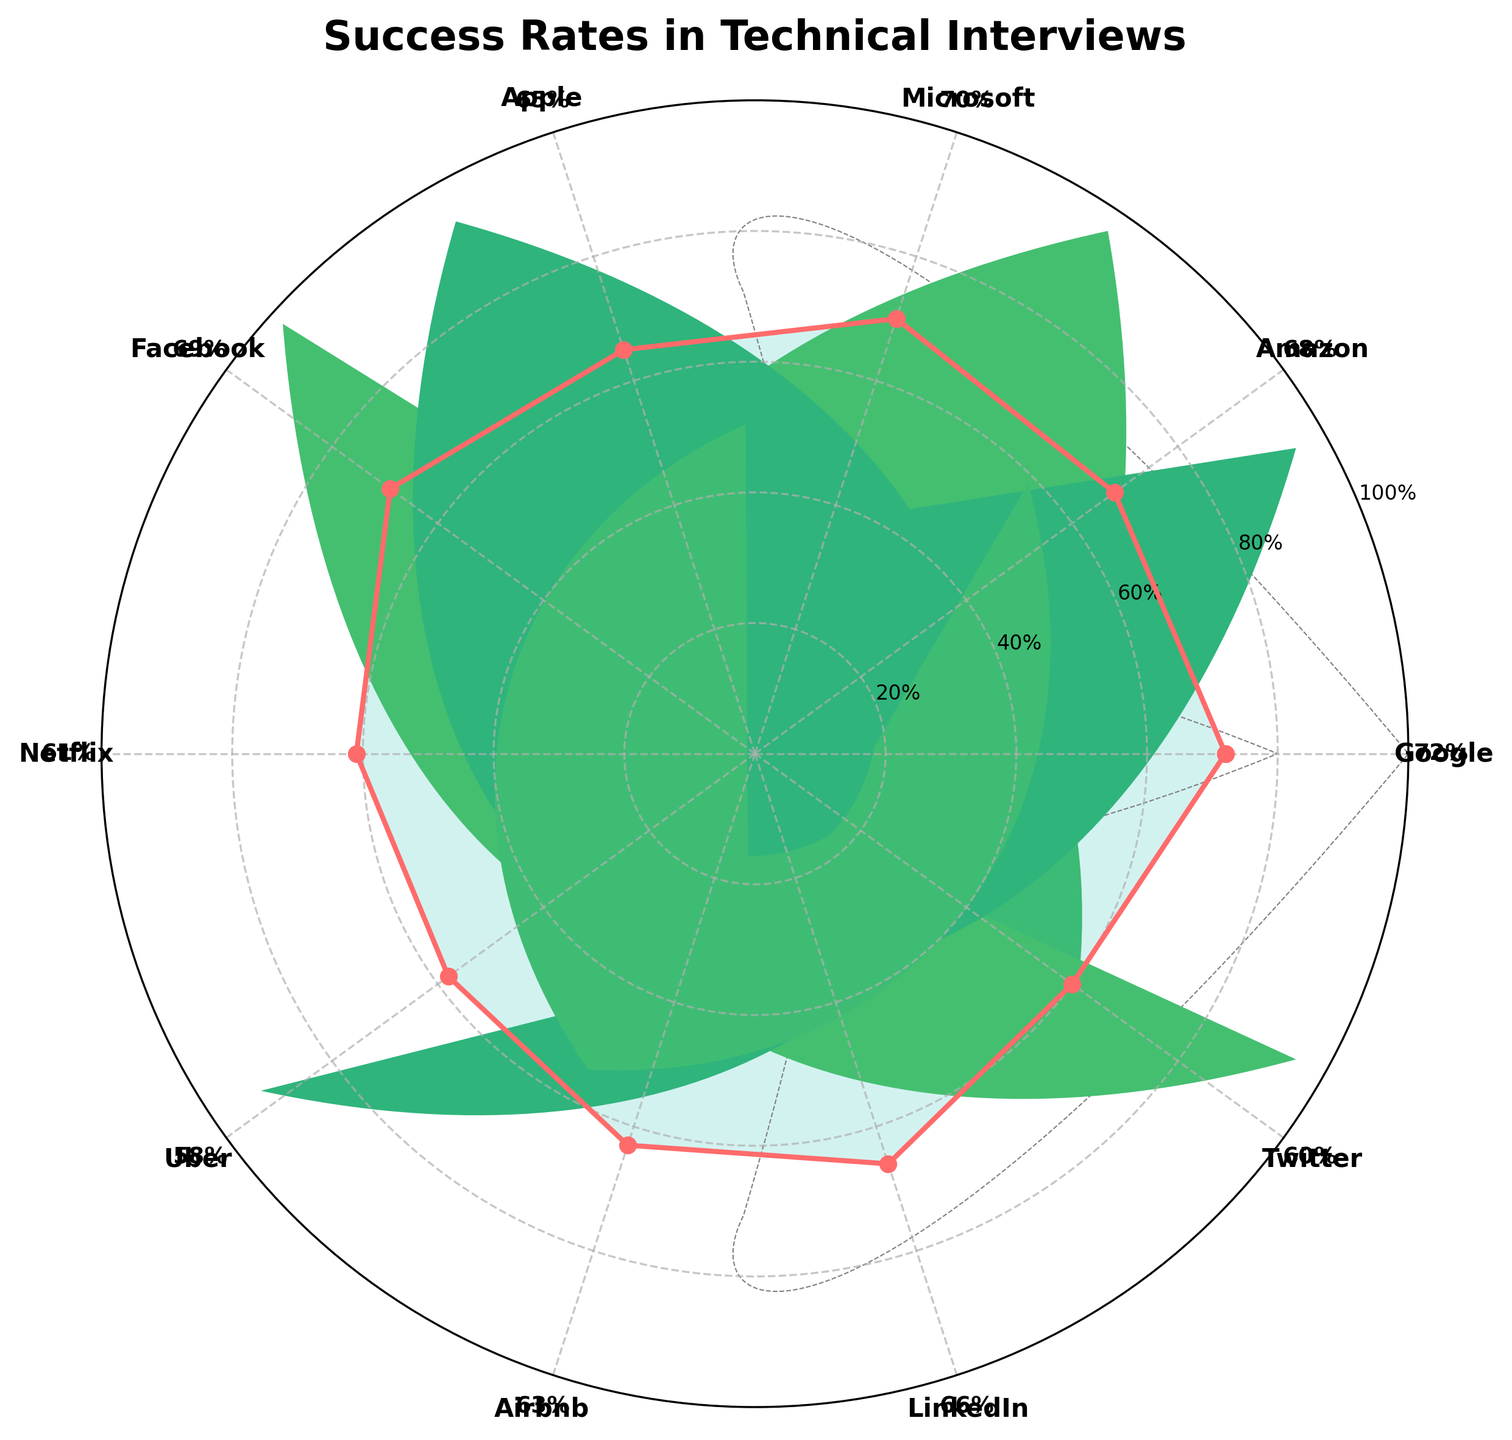what is the title of the figure? The title is displayed prominently at the top of the figure. It reads "Success Rates in Technical Interviews."
Answer: Success Rates in Technical Interviews which tech company has the highest success rate? By observing the polar plot and looking at the labels of the highest data point, Google has the highest success rate at 72%.
Answer: Google calculate the average success rate of all the companies? Add all the success rates (72, 68, 70, 65, 69, 61, 58, 63, 66, 60) and divide by the number of companies (10). The sum is 652, so the average is 652/10 = 65.2
Answer: 65.2 How does Netflix's success rate compare to Twitter's? From the figure, Netflix has a success rate of 61%, and Twitter has a success rate of 60%. Since 61% is greater than 60%, Netflix's success rate is slightly higher than Twitter's.
Answer: Netflix's success rate is higher Among Google, Amazon, and Microsoft, which company has a lower success rate than Google? Comparing the success rates on the plot, Google is 72%, Amazon is 68%, and Microsoft is 70%. Both Amazon and Microsoft have lower success rates than Google.
Answer: Amazon and Microsoft What is the difference in success rate between Uber and Airbnb? Uber has a success rate of 58% and Airbnb has 63%. The difference is 63% - 58% = 5%.
Answer: 5% Which company has the lowest success rate? Observing the polar plot, Uber has the lowest success rate, which is 58%.
Answer: Uber Rank the success rates of Apple, Facebook, and LinkedIn in ascending order. Apple has 65%, Facebook has 69%, and LinkedIn has 66%. In ascending order: Apple (65%), LinkedIn (66%), and Facebook (69%).
Answer: Apple, LinkedIn, Facebook What are the maximum and minimum values on the radial grid lines? The radial grid lines are labeled from 20% to 100%. The minimum value is 20%, and the maximum is 100%.
Answer: Minimum: 20%, Maximum: 100% Which two companies have success rates that are closest to each other? Examining neighboring data points on the polar plot, Facebook has 69% and Amazon has 68%. The difference is the smallest among all pairs, which is 1%.
Answer: Facebook and Amazon 